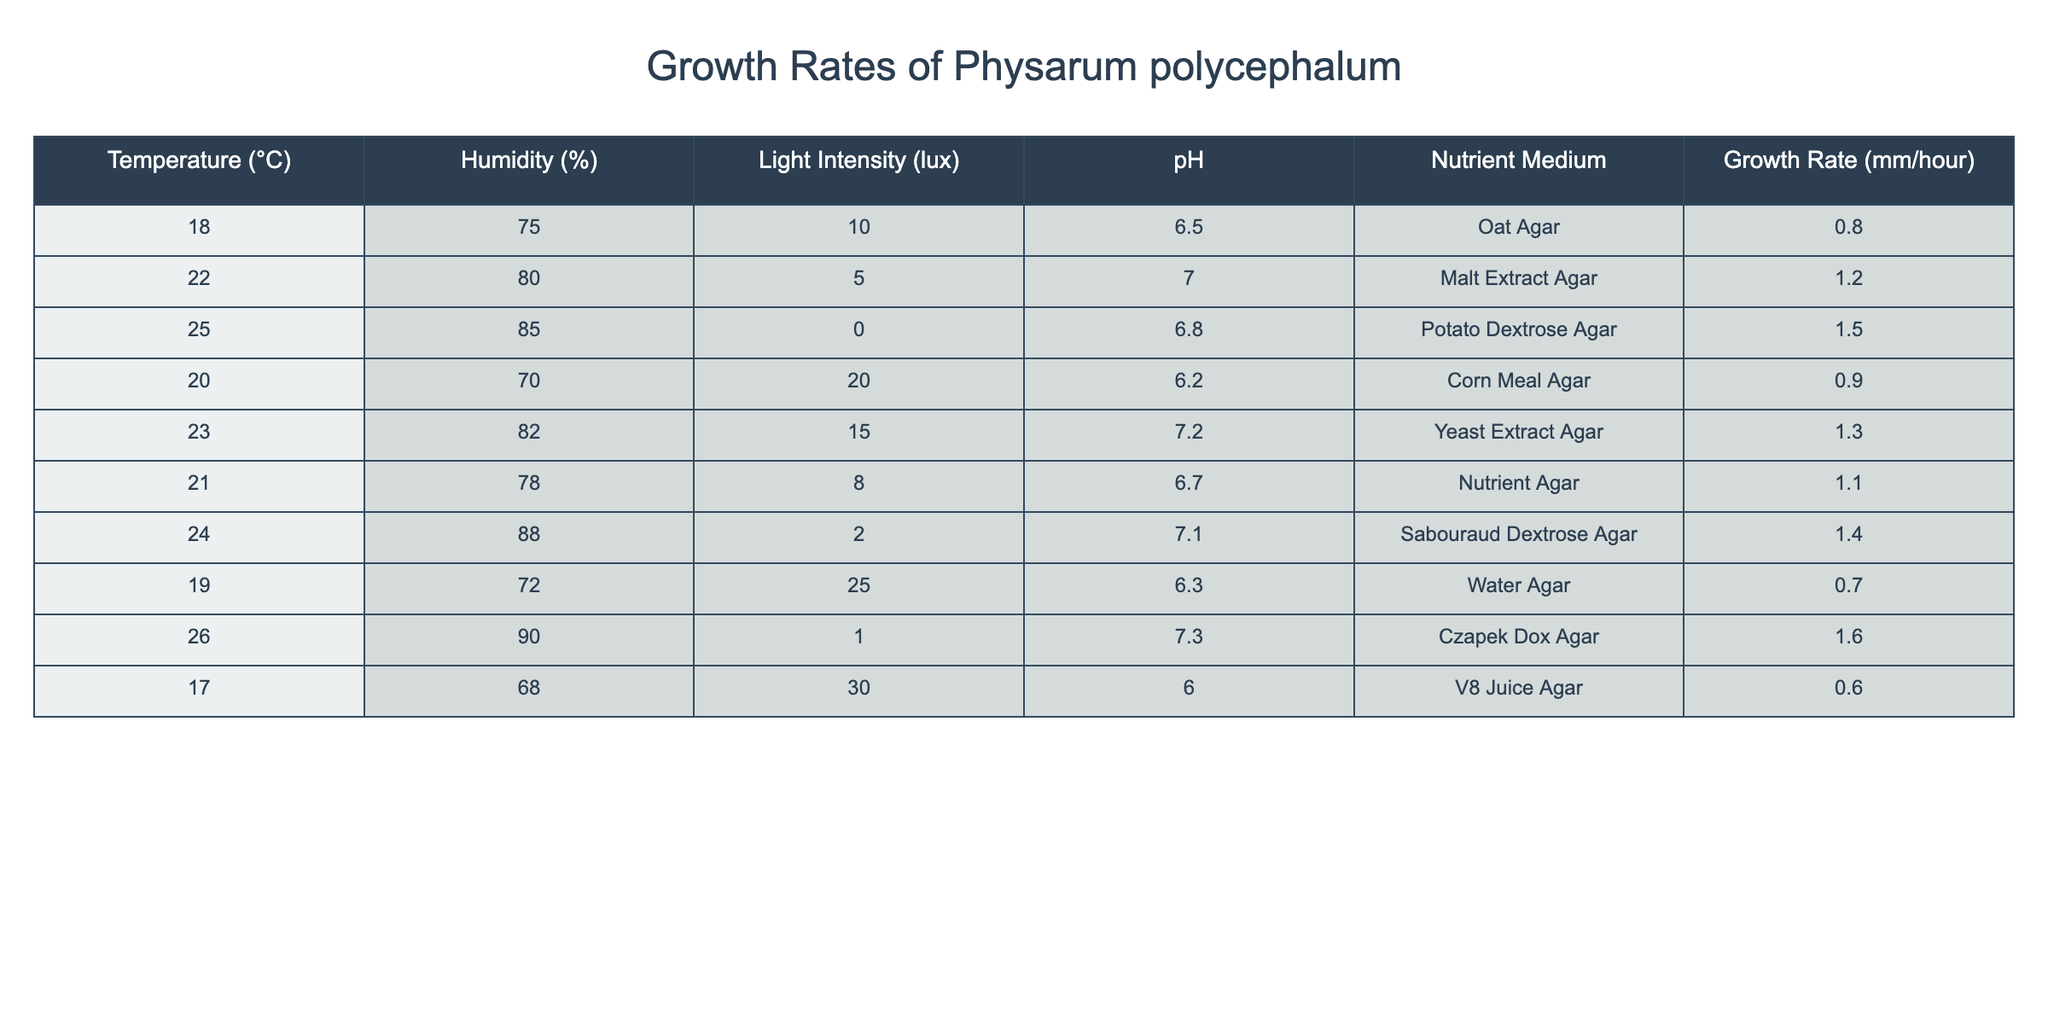What is the highest growth rate recorded for Physarum polycephalum? By looking at the "Growth Rate (mm/hour)" column, the maximum value is found. Scanning through the values, we see that 1.6 mm/hour is the highest growth rate.
Answer: 1.6 mm/hour Which nutrient medium is associated with a growth rate of 0.6 mm/hour? To answer this, we locate the growth rate of 0.6 mm/hour in the table. The corresponding nutrient medium is "V8 Juice Agar".
Answer: V8 Juice Agar What is the average growth rate across all conditions? To find the average, we first sum all the growth rates (0.8 + 1.2 + 1.5 + 0.9 + 1.3 + 1.1 + 1.4 + 0.7 + 1.6 + 0.6) = 11.1. Since there are 10 entries, we divide the sum by 10, leading to an average of 11.1/10 = 1.11 mm/hour.
Answer: 1.11 mm/hour Does growth rate increase with an increase in temperature? We need to assess the growth rates against the temperature values. Starting from the data, it appears that as temperature rises from 17°C to 26°C, the growth rate tends to increase. However, there is a drop at some points, indicating it's not consistently true.
Answer: No What pH condition corresponds to the lowest growth rate? We find the lowest growth rate in the table (0.6 mm/hour) and check its pH value. This growth rate occurs at a pH of 6.0.
Answer: 6.0 Which temperature and humidity combination yields a growth rate of 1.4 mm/hour? We look at the growth rate of 1.4 mm/hour in the table, and find it corresponds to a temperature of 24°C and a humidity of 88%.
Answer: 24°C and 88% What is the difference in growth rate between the conditions of 26°C and 18°C? We find the growth rate for 26°C (1.6 mm/hour) and for 18°C (0.8 mm/hour). The difference is 1.6 - 0.8 = 0.8 mm/hour.
Answer: 0.8 mm/hour Is there a correlation between light intensity and growth rate? A close examination of the "Light Intensity" column shows variations without a clear linear relationship; hence no definitive correlation can be established based on the values presented in the table.
Answer: No Which nutrient medium results in the highest growth rate at a pH of 7.0? The data reveals that at pH 7.0, the nutrient medium is "Malt Extract Agar" with a growth rate of 1.2 mm/hour, which is the highest recorded at this pH.
Answer: Malt Extract Agar What is the total growth rate of conditions above 21°C? We identify growth rates for conditions with temperatures above 21°C (1.5, 1.4, 1.6). Summing these gives 1.5 + 1.4 + 1.6 = 4.5 mm/hour.
Answer: 4.5 mm/hour 